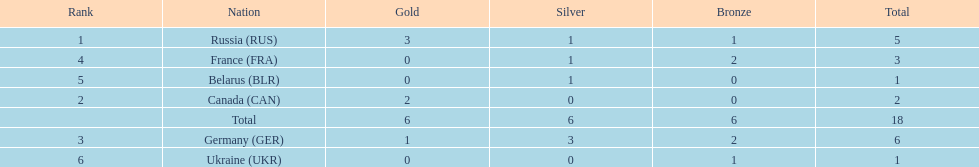Who had a larger total medal count, france or canada? France. 